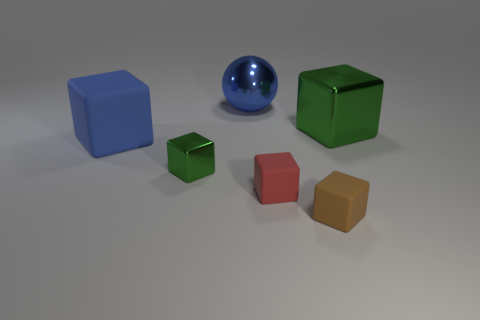What is the material of the small block to the right of the small matte block that is on the left side of the tiny brown matte object? The small block to the right of the smaller, matte block, which sits on the left side of the tiny brown matte object, appears to be made of rubber, given its particular texture and the way it interacts with light compared to the other objects in the image. Its surface is less reflective, suggesting a less shiny, more rubber-like finish. 